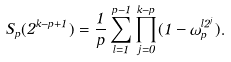<formula> <loc_0><loc_0><loc_500><loc_500>S _ { p } ( 2 ^ { k - p + 1 } ) = \frac { 1 } { p } \sum ^ { p - 1 } _ { l = 1 } \prod ^ { k - p } _ { j = 0 } ( 1 - \omega _ { p } ^ { l 2 ^ { j } } ) .</formula> 